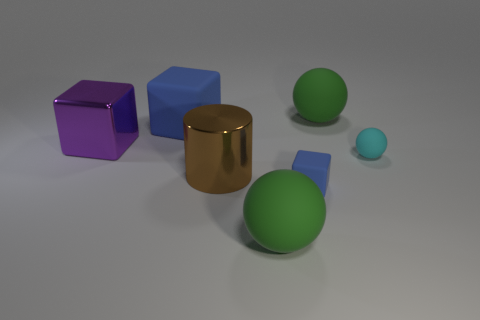Add 2 big brown cylinders. How many objects exist? 9 Subtract all big spheres. How many spheres are left? 1 Subtract all cyan spheres. How many blue cubes are left? 2 Subtract 1 spheres. How many spheres are left? 2 Subtract all spheres. How many objects are left? 4 Add 1 cyan spheres. How many cyan spheres are left? 2 Add 6 blue metallic cylinders. How many blue metallic cylinders exist? 6 Subtract 0 gray spheres. How many objects are left? 7 Subtract all cyan cylinders. Subtract all blue balls. How many cylinders are left? 1 Subtract all small objects. Subtract all cyan things. How many objects are left? 4 